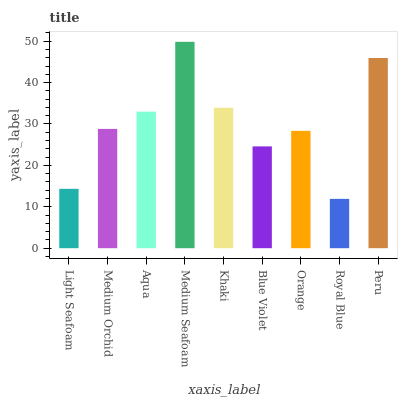Is Royal Blue the minimum?
Answer yes or no. Yes. Is Medium Seafoam the maximum?
Answer yes or no. Yes. Is Medium Orchid the minimum?
Answer yes or no. No. Is Medium Orchid the maximum?
Answer yes or no. No. Is Medium Orchid greater than Light Seafoam?
Answer yes or no. Yes. Is Light Seafoam less than Medium Orchid?
Answer yes or no. Yes. Is Light Seafoam greater than Medium Orchid?
Answer yes or no. No. Is Medium Orchid less than Light Seafoam?
Answer yes or no. No. Is Medium Orchid the high median?
Answer yes or no. Yes. Is Medium Orchid the low median?
Answer yes or no. Yes. Is Medium Seafoam the high median?
Answer yes or no. No. Is Khaki the low median?
Answer yes or no. No. 